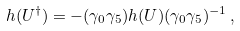<formula> <loc_0><loc_0><loc_500><loc_500>h ( U ^ { \dagger } ) = - ( \gamma _ { 0 } \gamma _ { 5 } ) h ( U ) ( \gamma _ { 0 } \gamma _ { 5 } ) ^ { - 1 } \, ,</formula> 